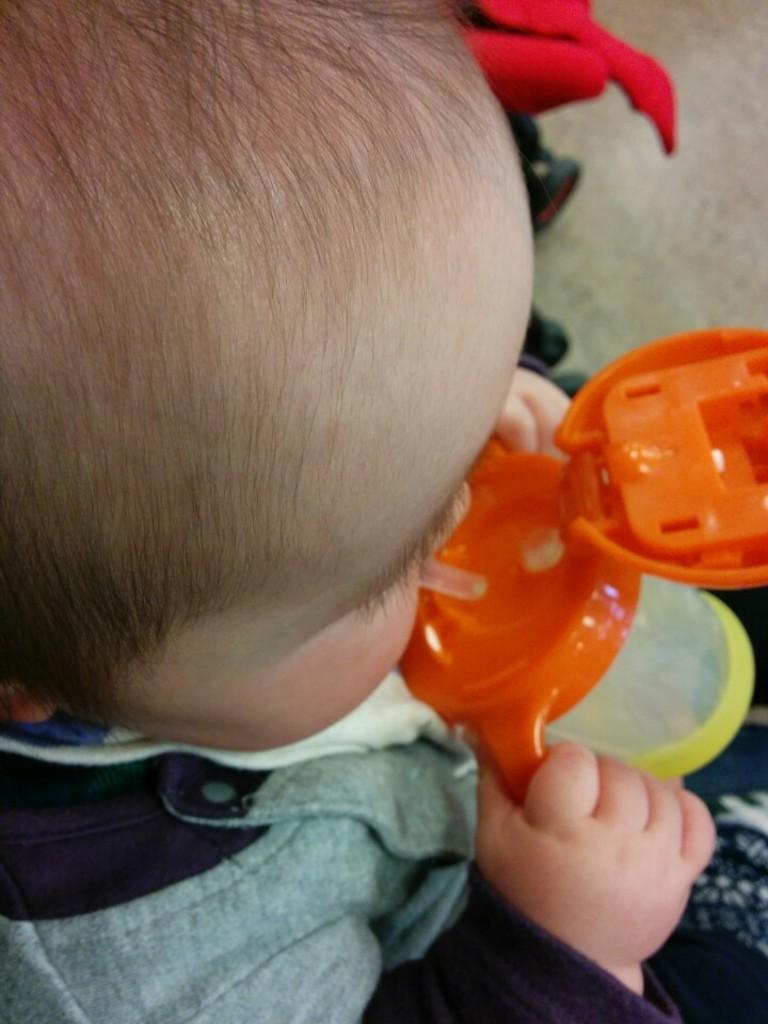What is the baby holding in the image? The baby is holding a slipper. Can you describe the color of the zipper in the image? The zipper is in orange and yellow color. What is the baby wearing in the image? The baby is wearing a black and gray dress. Is there a cord attached to the baby's dress in the image? No, there is no cord attached to the baby's dress in the image. 